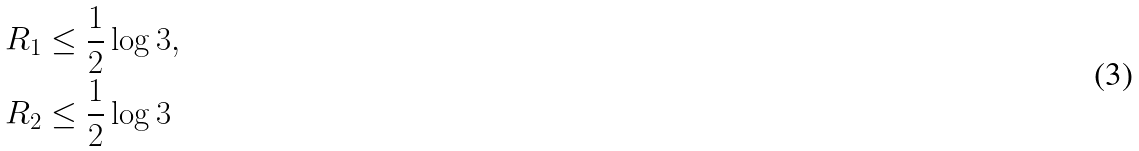<formula> <loc_0><loc_0><loc_500><loc_500>& R _ { 1 } \leq \frac { 1 } { 2 } \log 3 , \\ & R _ { 2 } \leq \frac { 1 } { 2 } \log 3</formula> 